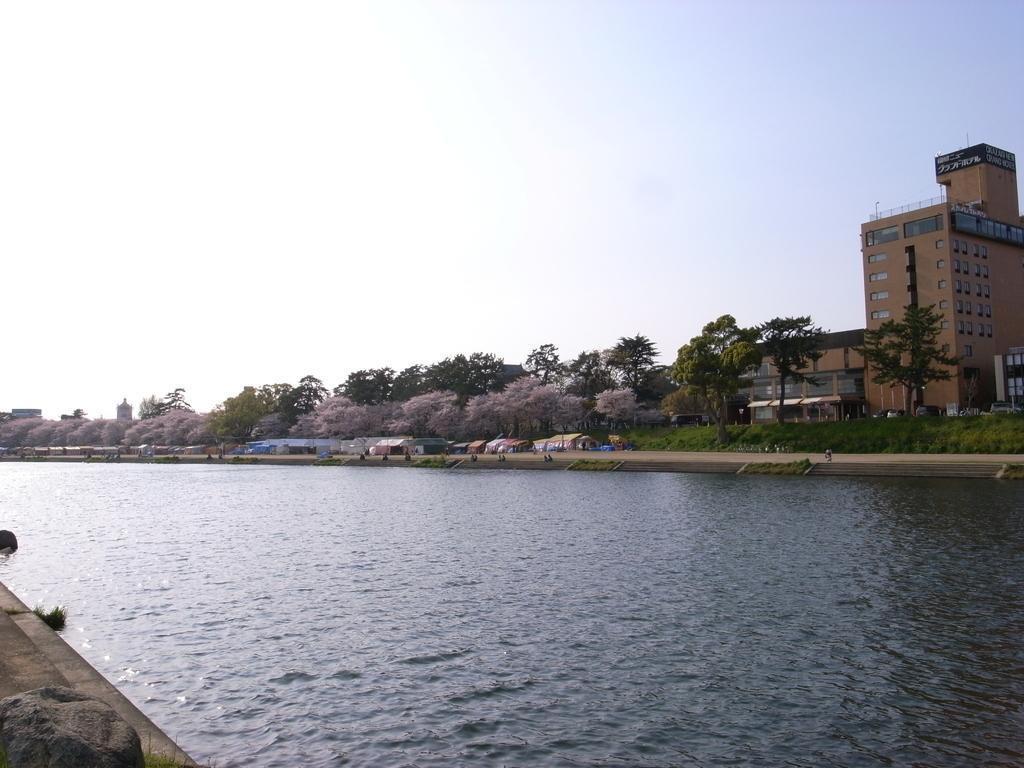Describe this image in one or two sentences. In this image I can see the water. In the background I can see few buildings, trees in green color and the sky is in white and blue color. 